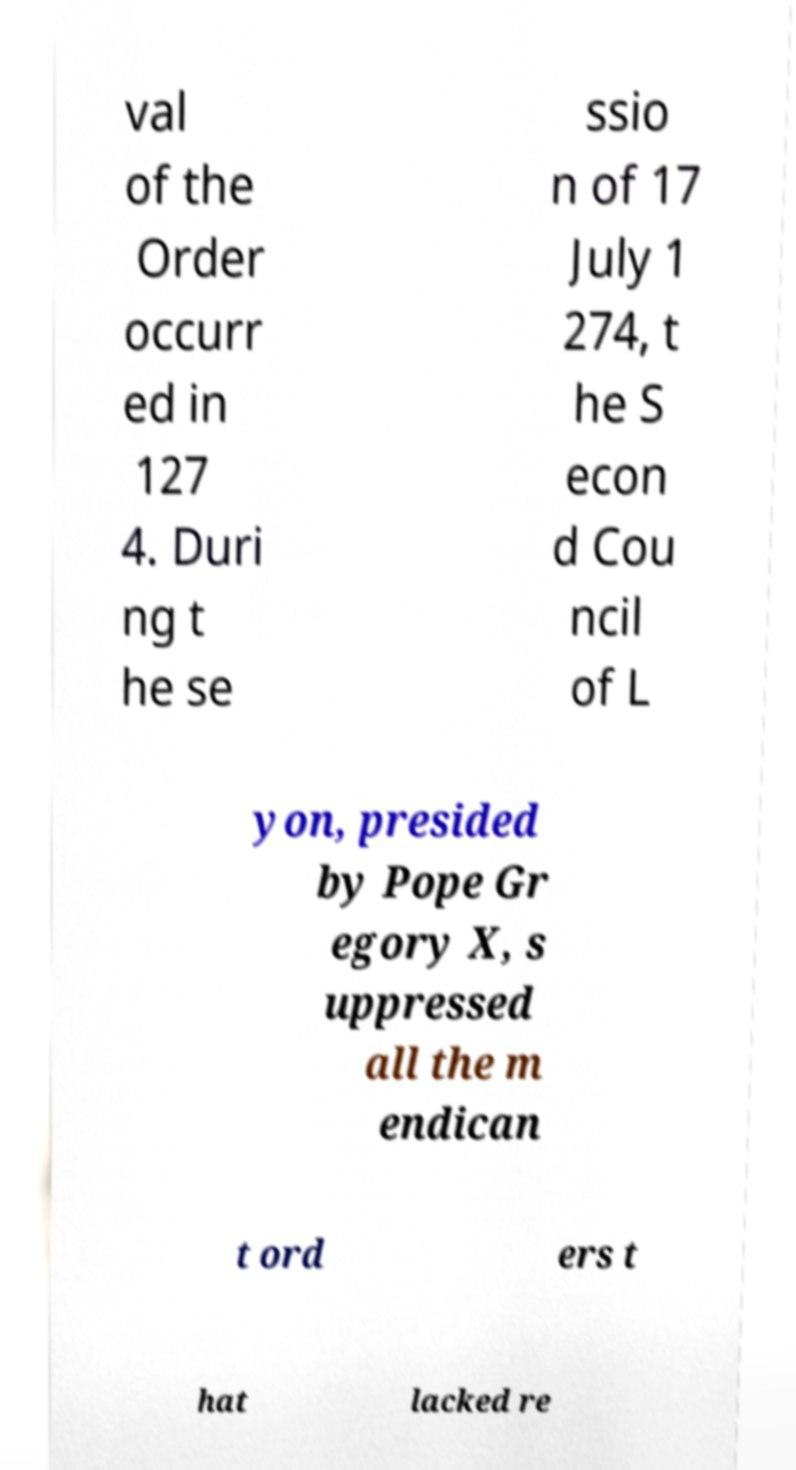Can you read and provide the text displayed in the image?This photo seems to have some interesting text. Can you extract and type it out for me? val of the Order occurr ed in 127 4. Duri ng t he se ssio n of 17 July 1 274, t he S econ d Cou ncil of L yon, presided by Pope Gr egory X, s uppressed all the m endican t ord ers t hat lacked re 